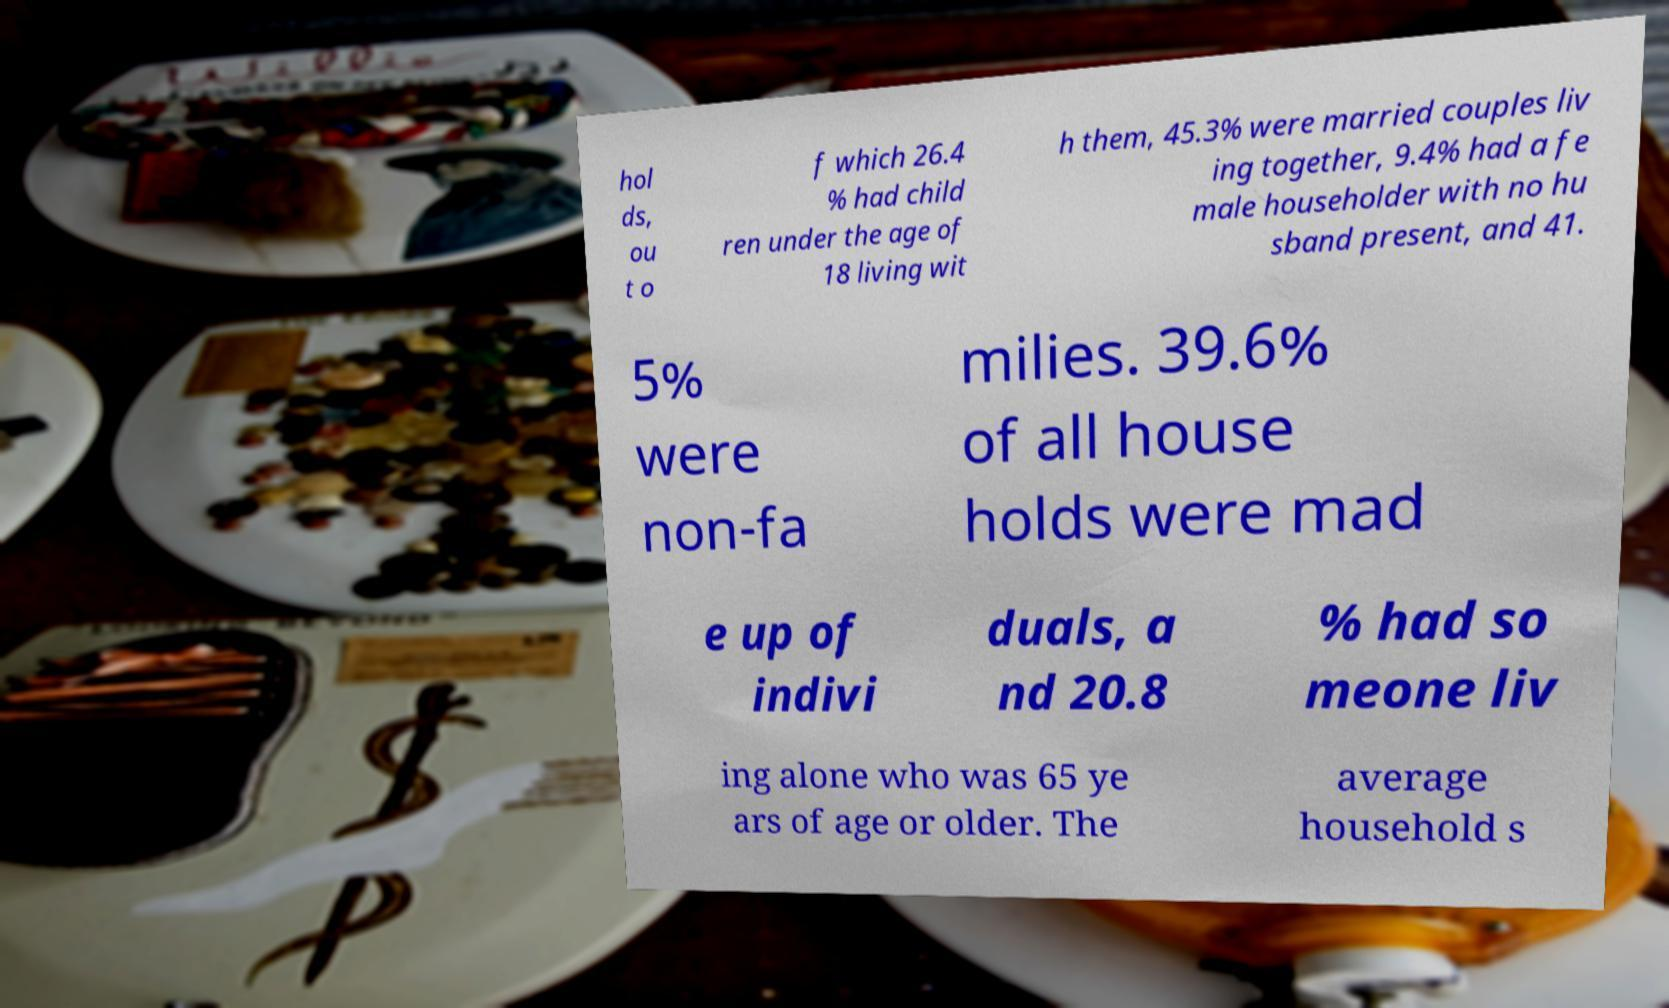Can you accurately transcribe the text from the provided image for me? hol ds, ou t o f which 26.4 % had child ren under the age of 18 living wit h them, 45.3% were married couples liv ing together, 9.4% had a fe male householder with no hu sband present, and 41. 5% were non-fa milies. 39.6% of all house holds were mad e up of indivi duals, a nd 20.8 % had so meone liv ing alone who was 65 ye ars of age or older. The average household s 